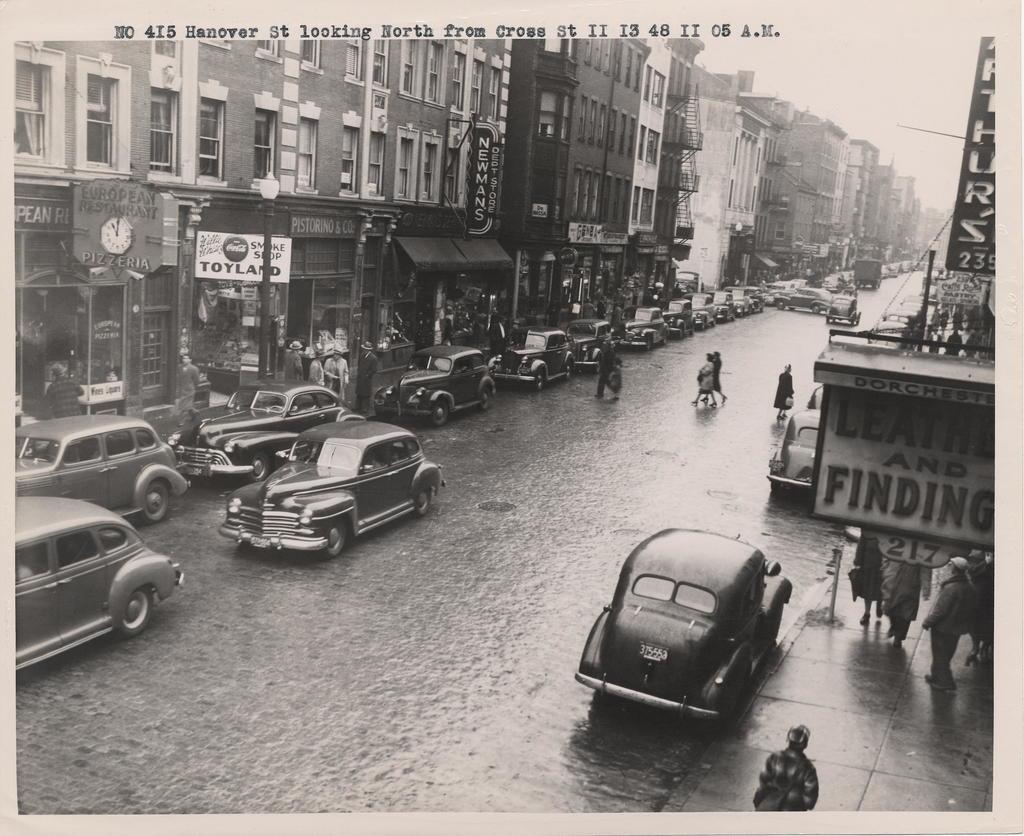In one or two sentences, can you explain what this image depicts? In this image there are so many vehicles moving on the road and few people are walking on the road and a few are standing on the pavement. On the right and left side of the image there are buildings, boards and poles. In the background there is some text. At the top of the image there is some text. 